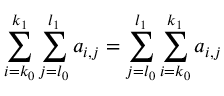<formula> <loc_0><loc_0><loc_500><loc_500>\sum _ { i = k _ { 0 } } ^ { k _ { 1 } } \sum _ { j = l _ { 0 } } ^ { l _ { 1 } } a _ { i , j } = \sum _ { j = l _ { 0 } } ^ { l _ { 1 } } \sum _ { i = k _ { 0 } } ^ { k _ { 1 } } a _ { i , j }</formula> 